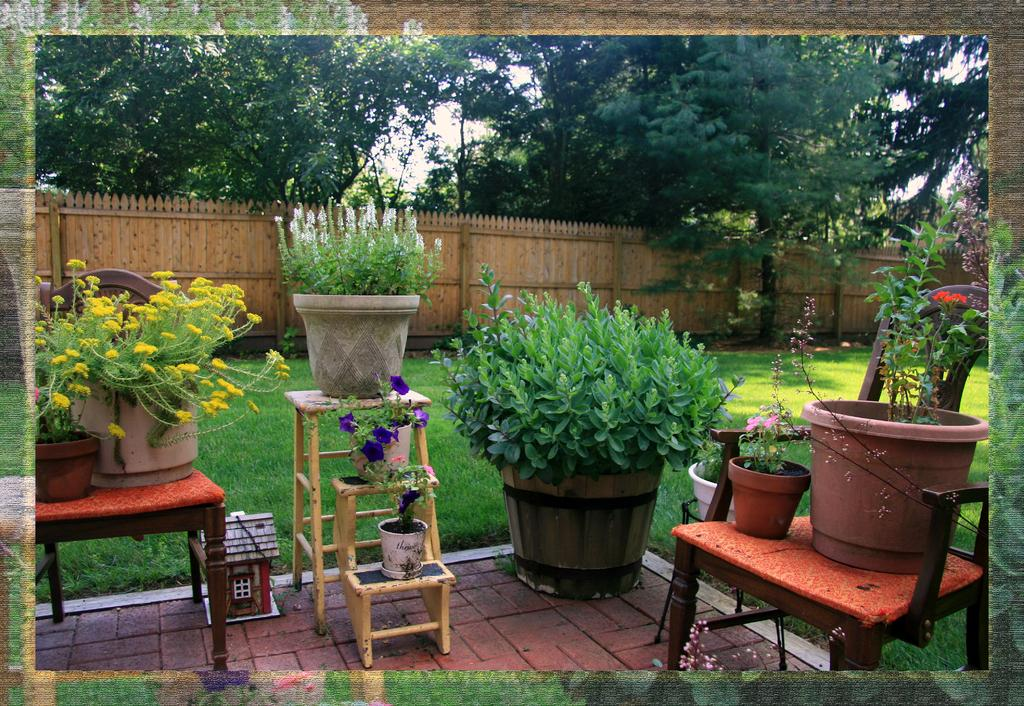What can be seen in the image in terms of plant containers? There are many flower pots in the image. What is visible in the background of the image? There is a wall, trees, and the sky visible in the background of the image. How many units of paper are stacked on the wall in the image? There is no paper stacked on the wall in the image; it only features flower pots, a wall, trees, and the sky. Can you spot an owl perched on one of the trees in the image? There is no owl present in the image; it only features flower pots, a wall, trees, and the sky. 